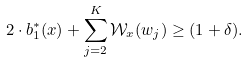Convert formula to latex. <formula><loc_0><loc_0><loc_500><loc_500>2 \cdot b _ { 1 } ^ { * } ( x ) + \sum _ { j = 2 } ^ { K } \mathcal { W } _ { x } ( w _ { j } ) \geq ( 1 + \delta ) .</formula> 